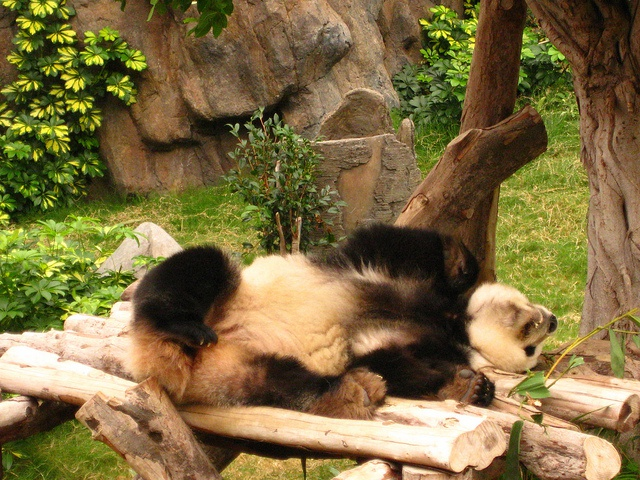Describe the objects in this image and their specific colors. I can see a bear in olive, black, tan, and maroon tones in this image. 